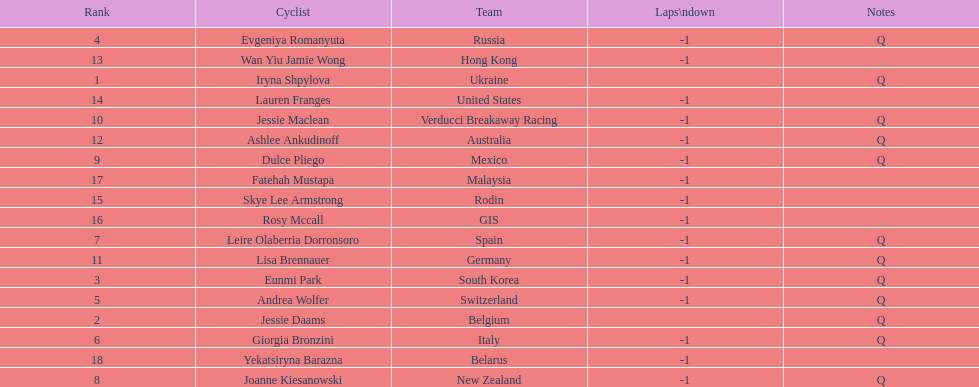Who are all of the cyclists in this race? Iryna Shpylova, Jessie Daams, Eunmi Park, Evgeniya Romanyuta, Andrea Wolfer, Giorgia Bronzini, Leire Olaberria Dorronsoro, Joanne Kiesanowski, Dulce Pliego, Jessie Maclean, Lisa Brennauer, Ashlee Ankudinoff, Wan Yiu Jamie Wong, Lauren Franges, Skye Lee Armstrong, Rosy Mccall, Fatehah Mustapa, Yekatsiryna Barazna. Of these, which one has the lowest numbered rank? Iryna Shpylova. 